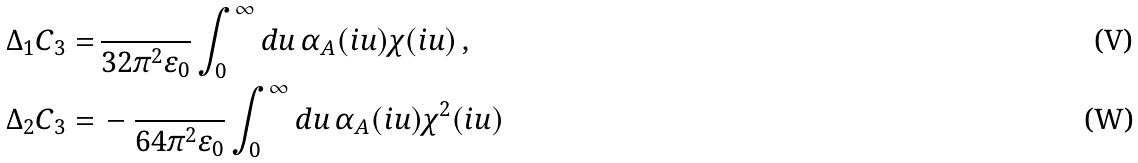Convert formula to latex. <formula><loc_0><loc_0><loc_500><loc_500>\Delta _ { 1 } C _ { 3 } = & \, \frac { } { 3 2 \pi ^ { 2 } \varepsilon _ { 0 } } \int _ { 0 } ^ { \infty } d u \, \alpha _ { A } ( i u ) \chi ( i u ) \, , \\ \Delta _ { 2 } C _ { 3 } = & \, - \frac { } { 6 4 \pi ^ { 2 } \varepsilon _ { 0 } } \int _ { 0 } ^ { \infty } d u \, \alpha _ { A } ( i u ) \chi ^ { 2 } ( i u )</formula> 